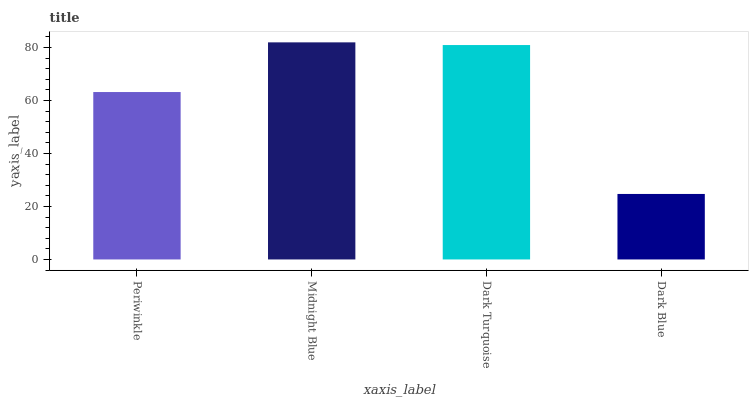Is Dark Blue the minimum?
Answer yes or no. Yes. Is Midnight Blue the maximum?
Answer yes or no. Yes. Is Dark Turquoise the minimum?
Answer yes or no. No. Is Dark Turquoise the maximum?
Answer yes or no. No. Is Midnight Blue greater than Dark Turquoise?
Answer yes or no. Yes. Is Dark Turquoise less than Midnight Blue?
Answer yes or no. Yes. Is Dark Turquoise greater than Midnight Blue?
Answer yes or no. No. Is Midnight Blue less than Dark Turquoise?
Answer yes or no. No. Is Dark Turquoise the high median?
Answer yes or no. Yes. Is Periwinkle the low median?
Answer yes or no. Yes. Is Midnight Blue the high median?
Answer yes or no. No. Is Dark Blue the low median?
Answer yes or no. No. 